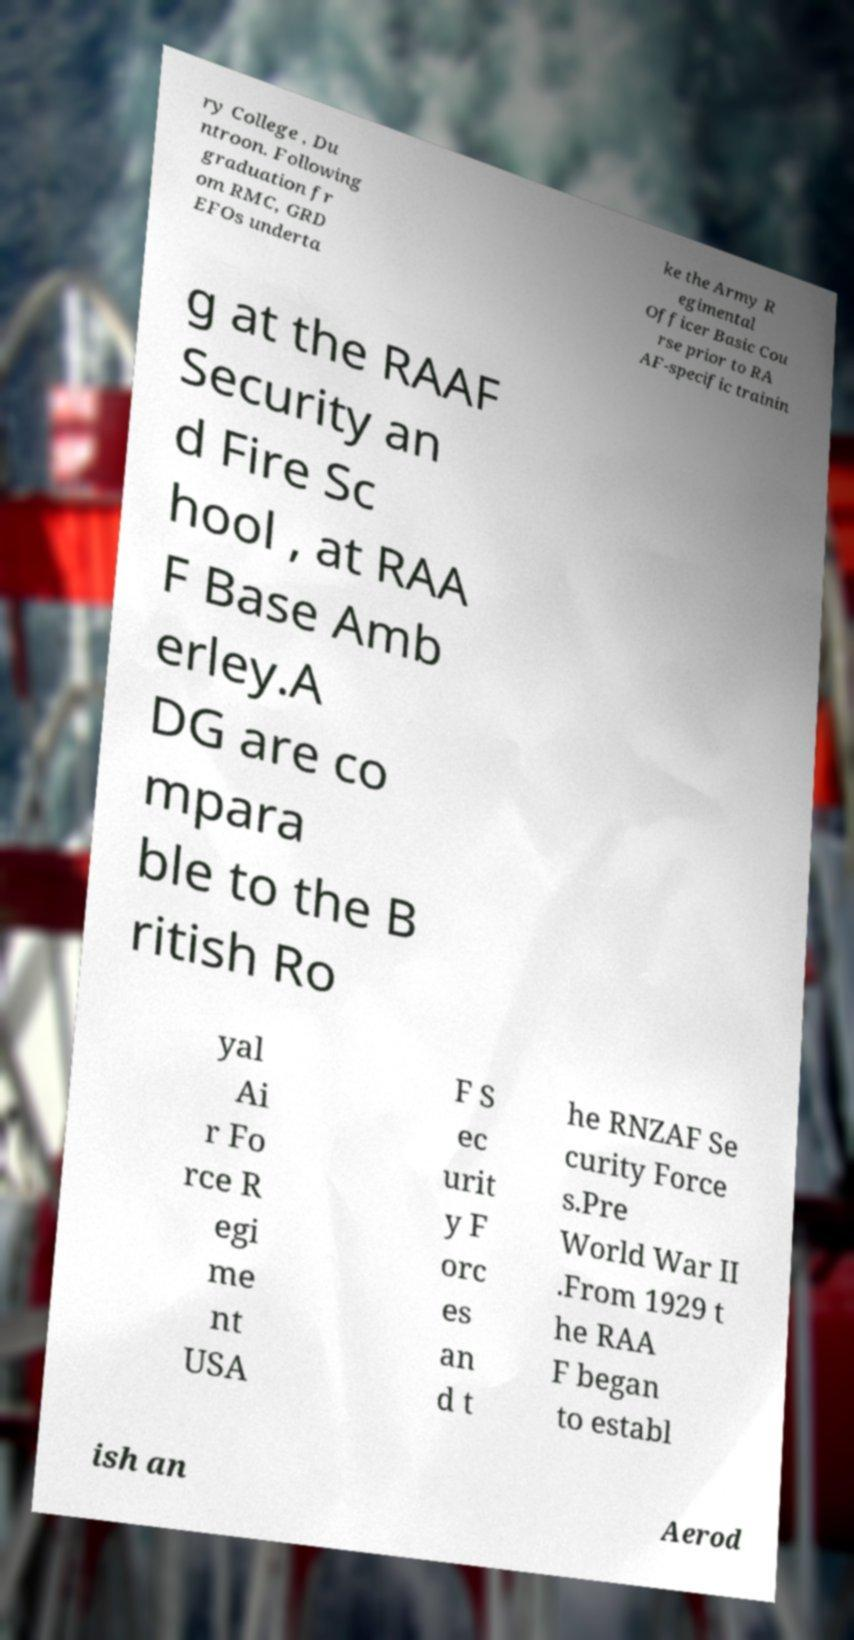I need the written content from this picture converted into text. Can you do that? ry College , Du ntroon. Following graduation fr om RMC, GRD EFOs underta ke the Army R egimental Officer Basic Cou rse prior to RA AF-specific trainin g at the RAAF Security an d Fire Sc hool , at RAA F Base Amb erley.A DG are co mpara ble to the B ritish Ro yal Ai r Fo rce R egi me nt USA F S ec urit y F orc es an d t he RNZAF Se curity Force s.Pre World War II .From 1929 t he RAA F began to establ ish an Aerod 